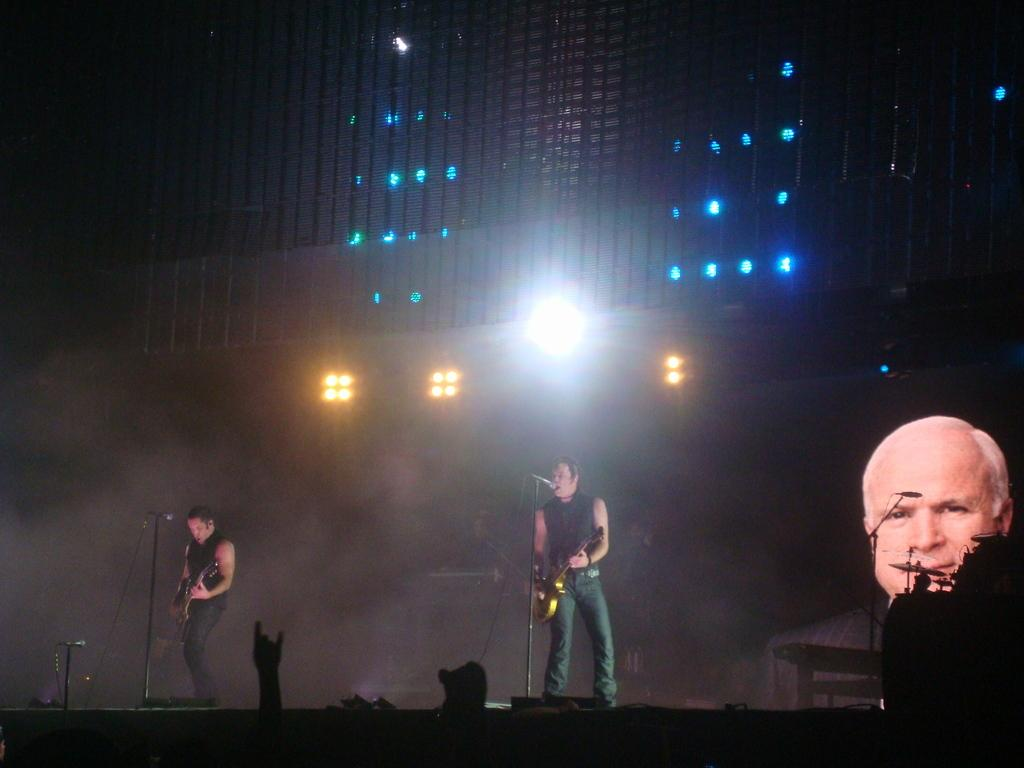What is happening in the image involving the group of people? Some people are playing guitar in the image. What objects are present to amplify the sound of the guitars? There are microphones in front of the guitar players. What can be seen in the background of the image? There are lights visible in the background of the image. Can you see a window in the image where the guitar players are performing? There is no window visible in the image; it only shows the guitar players and microphones. What type of sponge is being used by the guitar players to clean their instruments? There is no sponge present in the image, and the guitar players are not cleaning their instruments. 